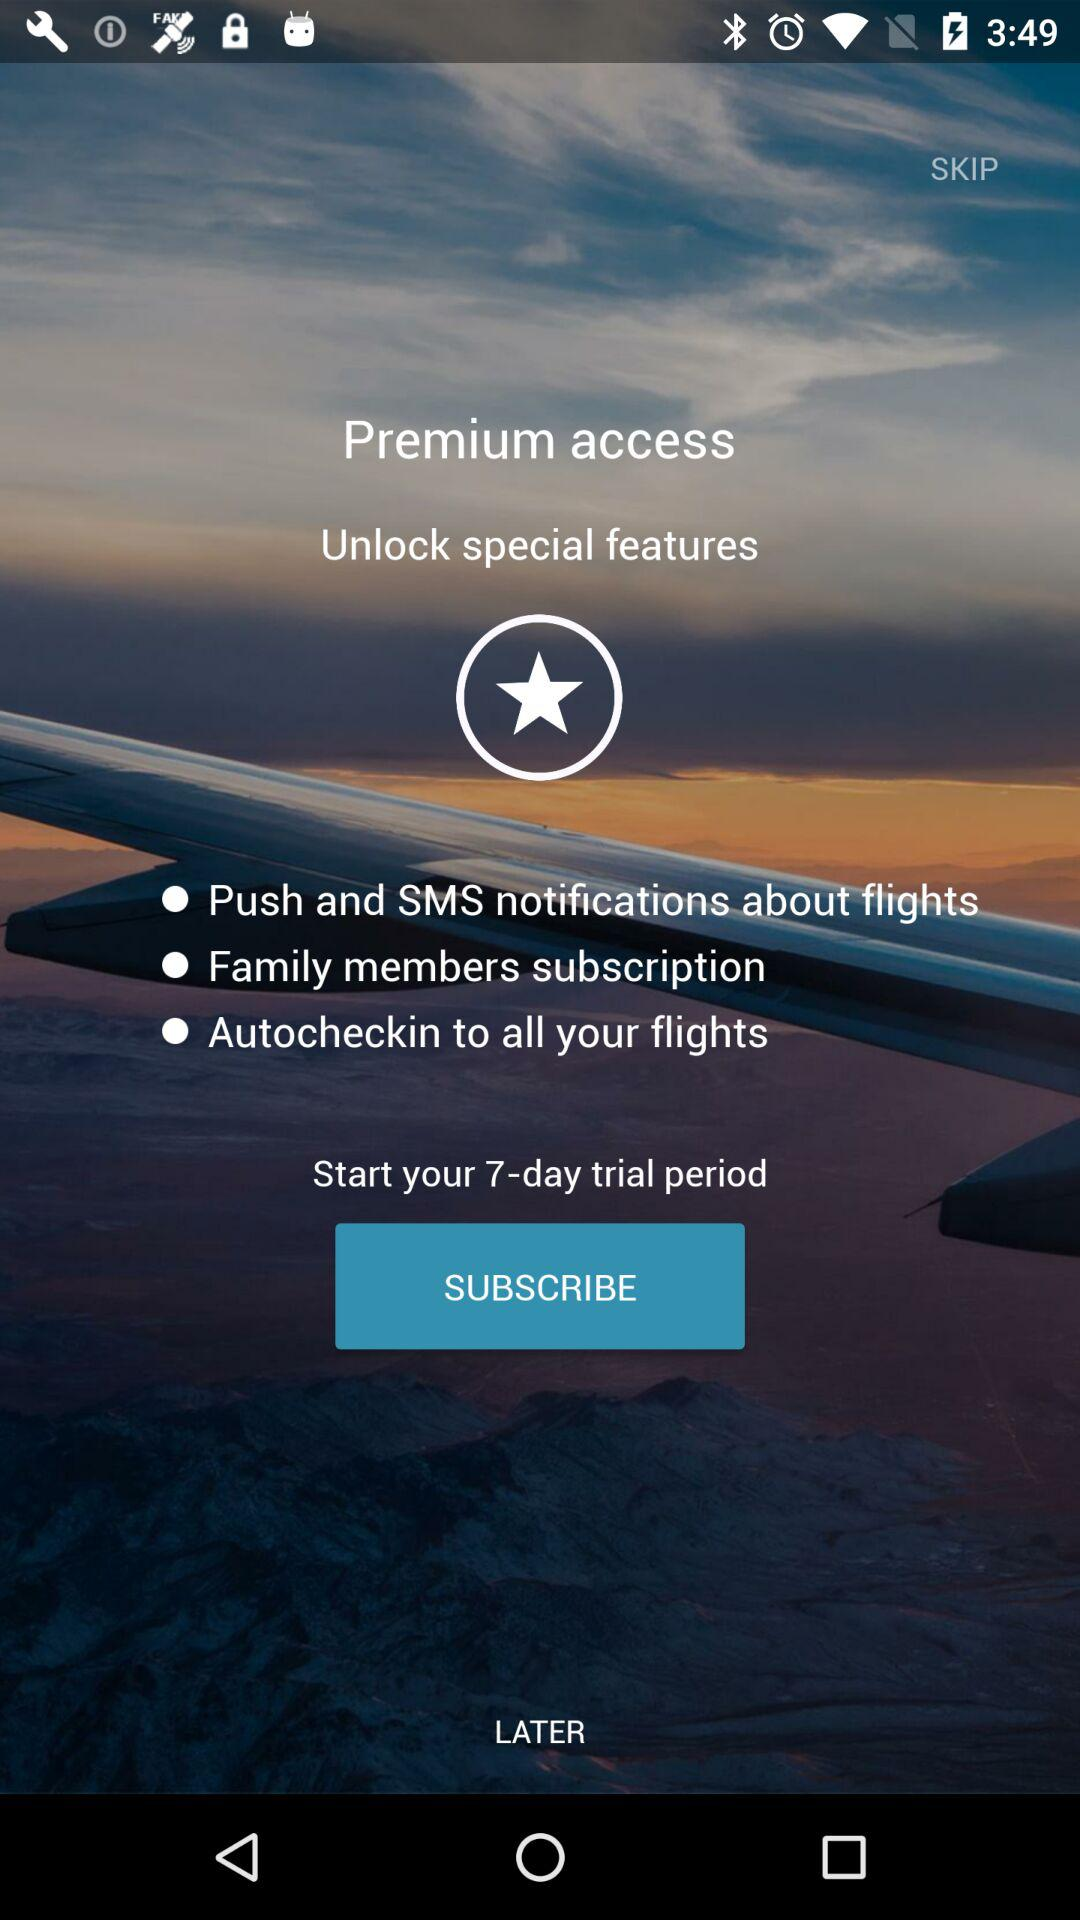How many special features can I unlock with a premium subscription?
Answer the question using a single word or phrase. 3 